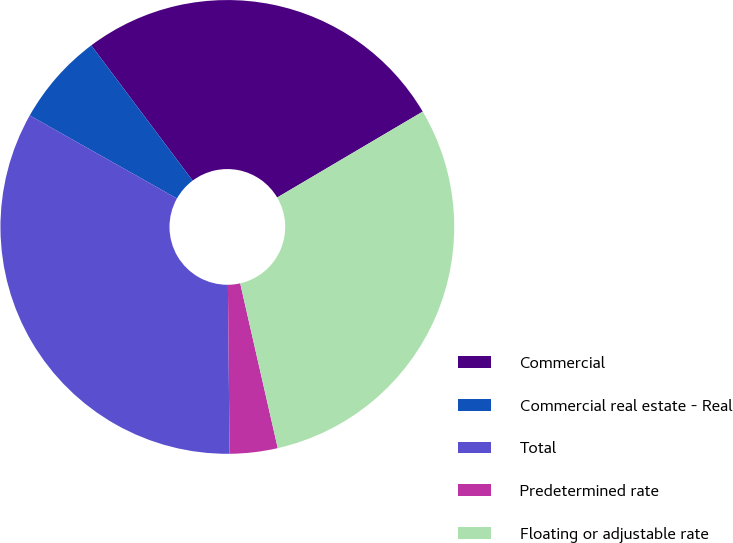Convert chart. <chart><loc_0><loc_0><loc_500><loc_500><pie_chart><fcel>Commercial<fcel>Commercial real estate - Real<fcel>Total<fcel>Predetermined rate<fcel>Floating or adjustable rate<nl><fcel>26.75%<fcel>6.59%<fcel>33.33%<fcel>3.41%<fcel>29.92%<nl></chart> 